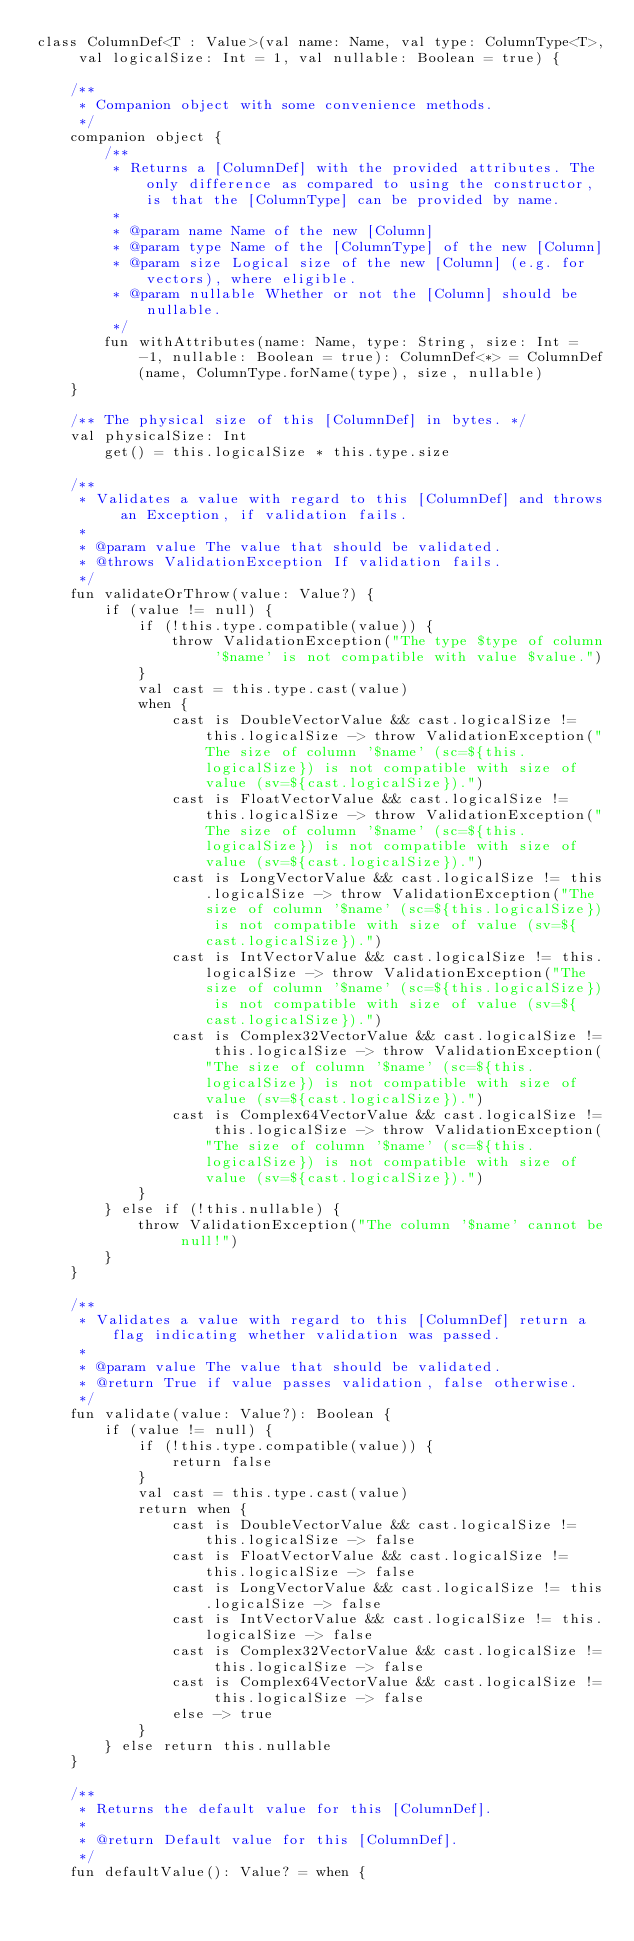Convert code to text. <code><loc_0><loc_0><loc_500><loc_500><_Kotlin_>class ColumnDef<T : Value>(val name: Name, val type: ColumnType<T>, val logicalSize: Int = 1, val nullable: Boolean = true) {

    /**
     * Companion object with some convenience methods.
     */
    companion object {
        /**
         * Returns a [ColumnDef] with the provided attributes. The only difference as compared to using the constructor, is that the [ColumnType] can be provided by name.
         *
         * @param name Name of the new [Column]
         * @param type Name of the [ColumnType] of the new [Column]
         * @param size Logical size of the new [Column] (e.g. for vectors), where eligible.
         * @param nullable Whether or not the [Column] should be nullable.
         */
        fun withAttributes(name: Name, type: String, size: Int = -1, nullable: Boolean = true): ColumnDef<*> = ColumnDef(name, ColumnType.forName(type), size, nullable)
    }

    /** The physical size of this [ColumnDef] in bytes. */
    val physicalSize: Int
        get() = this.logicalSize * this.type.size

    /**
     * Validates a value with regard to this [ColumnDef] and throws an Exception, if validation fails.
     *
     * @param value The value that should be validated.
     * @throws ValidationException If validation fails.
     */
    fun validateOrThrow(value: Value?) {
        if (value != null) {
            if (!this.type.compatible(value)) {
                throw ValidationException("The type $type of column '$name' is not compatible with value $value.")
            }
            val cast = this.type.cast(value)
            when {
                cast is DoubleVectorValue && cast.logicalSize != this.logicalSize -> throw ValidationException("The size of column '$name' (sc=${this.logicalSize}) is not compatible with size of value (sv=${cast.logicalSize}).")
                cast is FloatVectorValue && cast.logicalSize != this.logicalSize -> throw ValidationException("The size of column '$name' (sc=${this.logicalSize}) is not compatible with size of value (sv=${cast.logicalSize}).")
                cast is LongVectorValue && cast.logicalSize != this.logicalSize -> throw ValidationException("The size of column '$name' (sc=${this.logicalSize}) is not compatible with size of value (sv=${cast.logicalSize}).")
                cast is IntVectorValue && cast.logicalSize != this.logicalSize -> throw ValidationException("The size of column '$name' (sc=${this.logicalSize}) is not compatible with size of value (sv=${cast.logicalSize}).")
                cast is Complex32VectorValue && cast.logicalSize != this.logicalSize -> throw ValidationException("The size of column '$name' (sc=${this.logicalSize}) is not compatible with size of value (sv=${cast.logicalSize}).")
                cast is Complex64VectorValue && cast.logicalSize != this.logicalSize -> throw ValidationException("The size of column '$name' (sc=${this.logicalSize}) is not compatible with size of value (sv=${cast.logicalSize}).")
            }
        } else if (!this.nullable) {
            throw ValidationException("The column '$name' cannot be null!")
        }
    }

    /**
     * Validates a value with regard to this [ColumnDef] return a flag indicating whether validation was passed.
     *
     * @param value The value that should be validated.
     * @return True if value passes validation, false otherwise.
     */
    fun validate(value: Value?): Boolean {
        if (value != null) {
            if (!this.type.compatible(value)) {
                return false
            }
            val cast = this.type.cast(value)
            return when {
                cast is DoubleVectorValue && cast.logicalSize != this.logicalSize -> false
                cast is FloatVectorValue && cast.logicalSize != this.logicalSize -> false
                cast is LongVectorValue && cast.logicalSize != this.logicalSize -> false
                cast is IntVectorValue && cast.logicalSize != this.logicalSize -> false
                cast is Complex32VectorValue && cast.logicalSize != this.logicalSize -> false
                cast is Complex64VectorValue && cast.logicalSize != this.logicalSize -> false
                else -> true
            }
        } else return this.nullable
    }

    /**
     * Returns the default value for this [ColumnDef].
     *
     * @return Default value for this [ColumnDef].
     */
    fun defaultValue(): Value? = when {</code> 